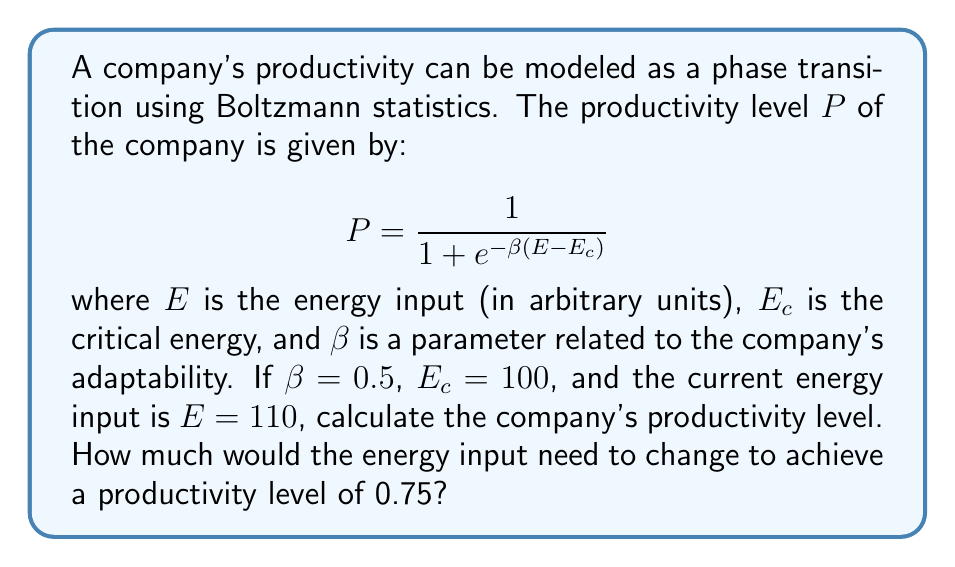Provide a solution to this math problem. Let's approach this problem step-by-step:

1. Given information:
   $\beta = 0.5$
   $E_c = 100$
   $E = 110$

2. Calculate the current productivity level:
   $$P = \frac{1}{1 + e^{-\beta(E-E_c)}}$$
   $$P = \frac{1}{1 + e^{-0.5(110-100)}}$$
   $$P = \frac{1}{1 + e^{-5}}$$
   $$P \approx 0.9933$$

3. To find the energy input needed for a productivity level of 0.75, we need to solve:
   $$0.75 = \frac{1}{1 + e^{-0.5(E-100)}}$$

4. Rearranging the equation:
   $$1 + e^{-0.5(E-100)} = \frac{1}{0.75}$$
   $$e^{-0.5(E-100)} = \frac{1}{0.75} - 1 = \frac{1}{3}$$

5. Taking the natural log of both sides:
   $$-0.5(E-100) = \ln(\frac{1}{3})$$

6. Solving for E:
   $$E-100 = -2\ln(\frac{1}{3})$$
   $$E = 100 - 2\ln(\frac{1}{3})$$
   $$E \approx 102.2$$

7. The change in energy input needed:
   $$\Delta E = 102.2 - 110 = -7.8$$
Answer: Current productivity: 0.9933; Energy change needed: -7.8 units 